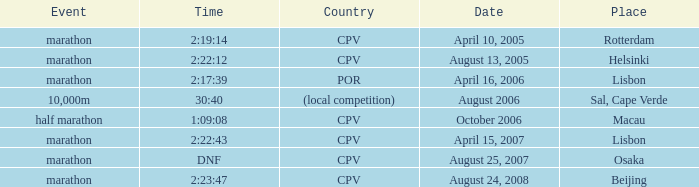What is the Place of the Event on August 25, 2007? Osaka. 